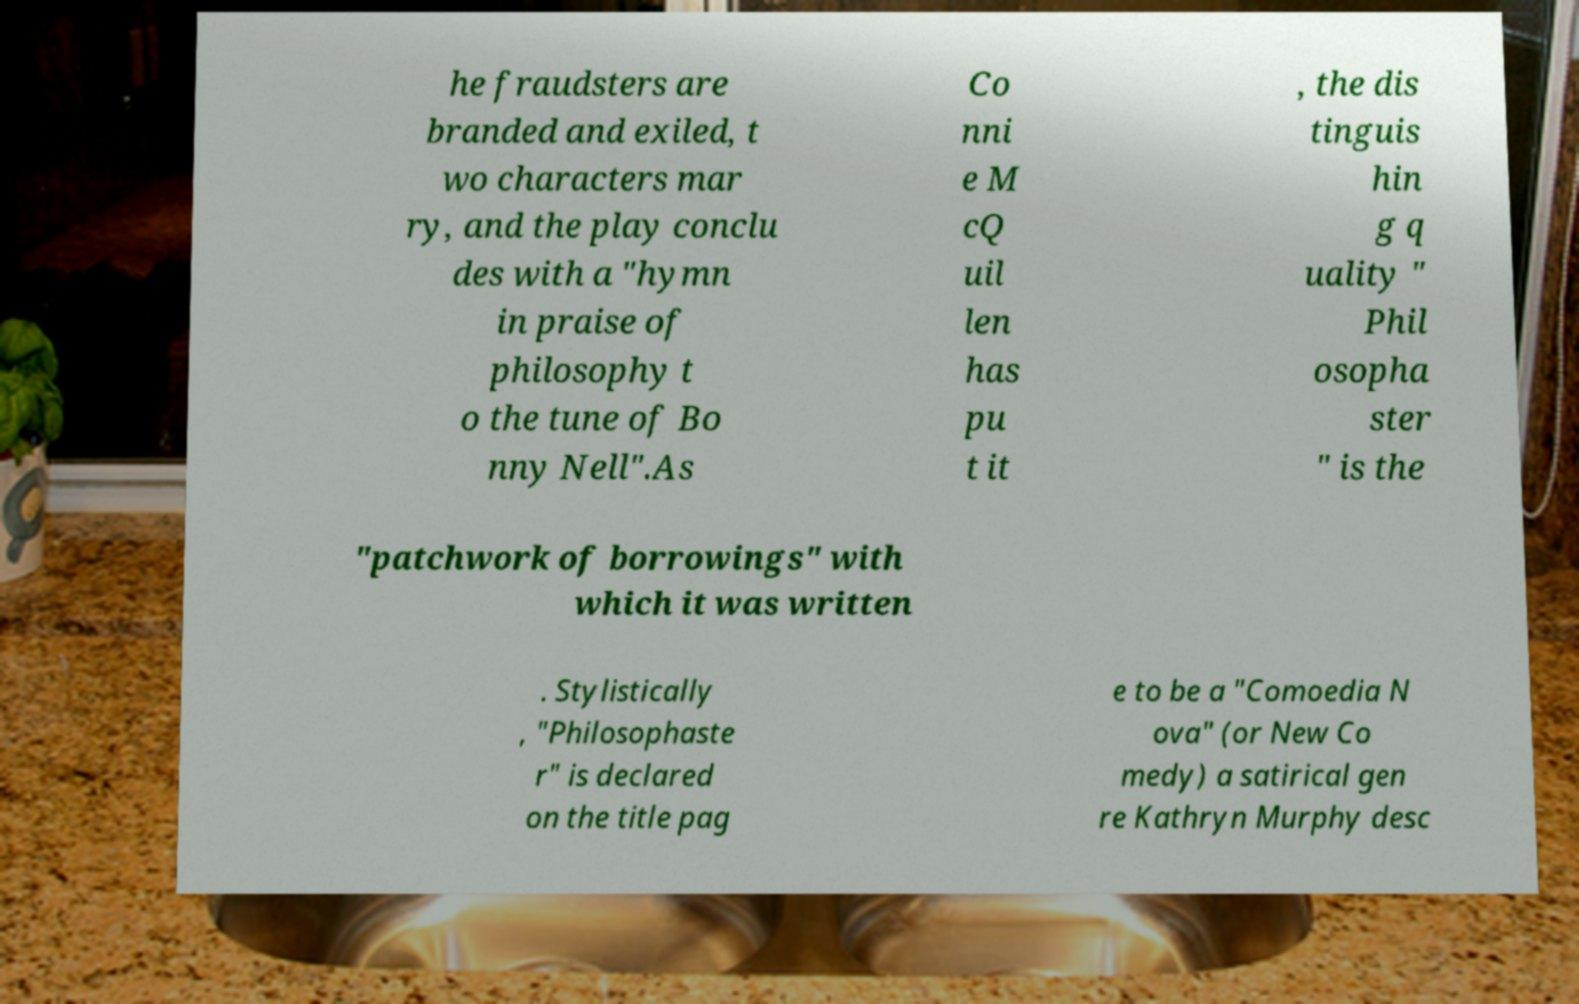I need the written content from this picture converted into text. Can you do that? he fraudsters are branded and exiled, t wo characters mar ry, and the play conclu des with a "hymn in praise of philosophy t o the tune of Bo nny Nell".As Co nni e M cQ uil len has pu t it , the dis tinguis hin g q uality " Phil osopha ster " is the "patchwork of borrowings" with which it was written . Stylistically , "Philosophaste r" is declared on the title pag e to be a "Comoedia N ova" (or New Co medy) a satirical gen re Kathryn Murphy desc 